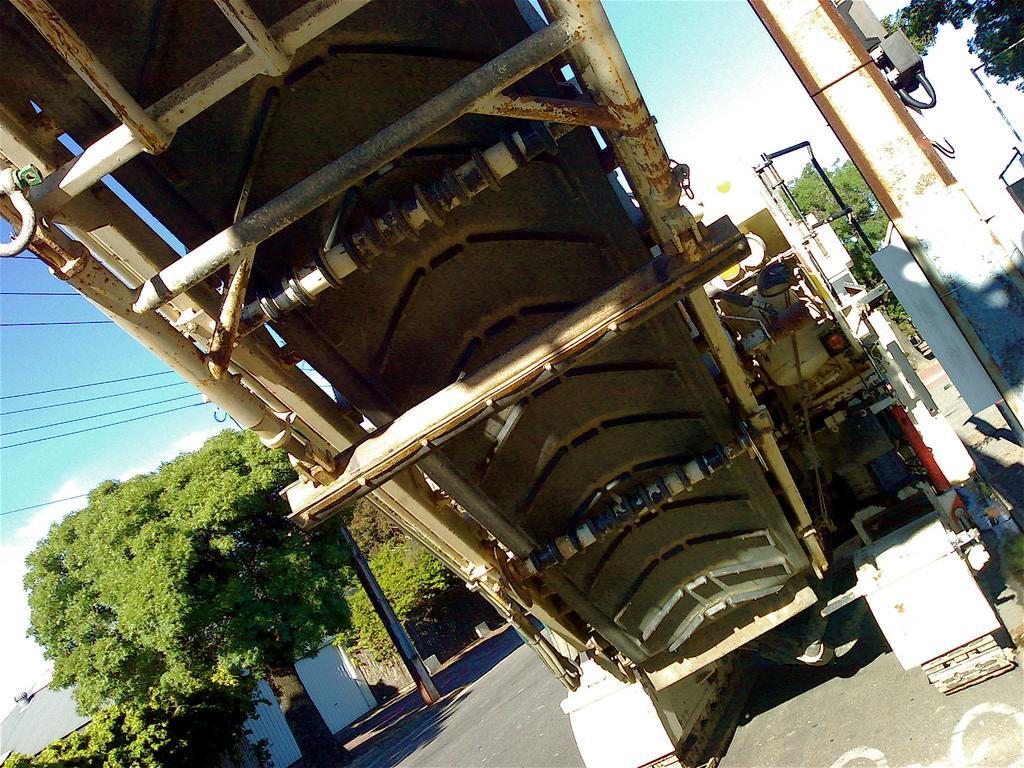How would you summarize this image in a sentence or two? In the picture we can see a backside of the steps and besides, we can see a pillar and some poles and in the background, we can see a pole on the path and a tree and a sky with clouds and we can also see some wires. 